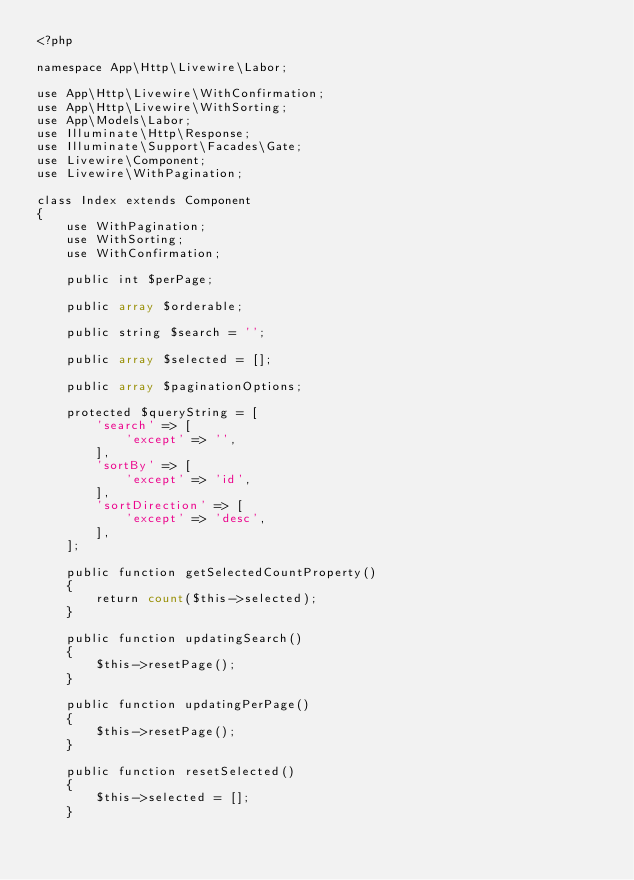Convert code to text. <code><loc_0><loc_0><loc_500><loc_500><_PHP_><?php

namespace App\Http\Livewire\Labor;

use App\Http\Livewire\WithConfirmation;
use App\Http\Livewire\WithSorting;
use App\Models\Labor;
use Illuminate\Http\Response;
use Illuminate\Support\Facades\Gate;
use Livewire\Component;
use Livewire\WithPagination;

class Index extends Component
{
    use WithPagination;
    use WithSorting;
    use WithConfirmation;

    public int $perPage;

    public array $orderable;

    public string $search = '';

    public array $selected = [];

    public array $paginationOptions;

    protected $queryString = [
        'search' => [
            'except' => '',
        ],
        'sortBy' => [
            'except' => 'id',
        ],
        'sortDirection' => [
            'except' => 'desc',
        ],
    ];

    public function getSelectedCountProperty()
    {
        return count($this->selected);
    }

    public function updatingSearch()
    {
        $this->resetPage();
    }

    public function updatingPerPage()
    {
        $this->resetPage();
    }

    public function resetSelected()
    {
        $this->selected = [];
    }
</code> 